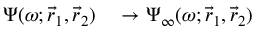Convert formula to latex. <formula><loc_0><loc_0><loc_500><loc_500>\begin{array} { r l } { \Psi ( \omega ; \vec { r } _ { 1 } , \vec { r } _ { 2 } ) } & \to \Psi _ { \infty } ( \omega ; \vec { r } _ { 1 } , \vec { r } _ { 2 } ) } \end{array}</formula> 